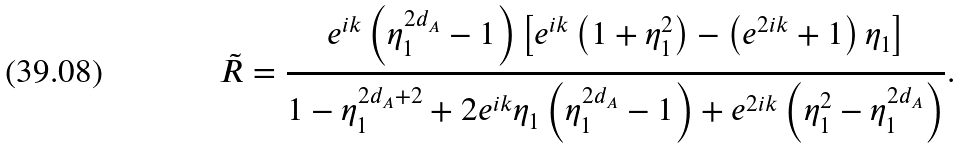<formula> <loc_0><loc_0><loc_500><loc_500>\tilde { R } = \frac { e ^ { i k } \left ( \eta _ { 1 } ^ { 2 d _ { A } } - 1 \right ) \left [ e ^ { i k } \left ( 1 + \eta _ { 1 } ^ { 2 } \right ) - \left ( e ^ { 2 i k } + 1 \right ) \eta _ { 1 } \right ] } { 1 - \eta _ { 1 } ^ { 2 d _ { A } + 2 } + 2 e ^ { i k } \eta _ { 1 } \left ( \eta _ { 1 } ^ { 2 d _ { A } } - 1 \right ) + e ^ { 2 i k } \left ( \eta _ { 1 } ^ { 2 } - \eta _ { 1 } ^ { 2 d _ { A } } \right ) } \text {.}</formula> 